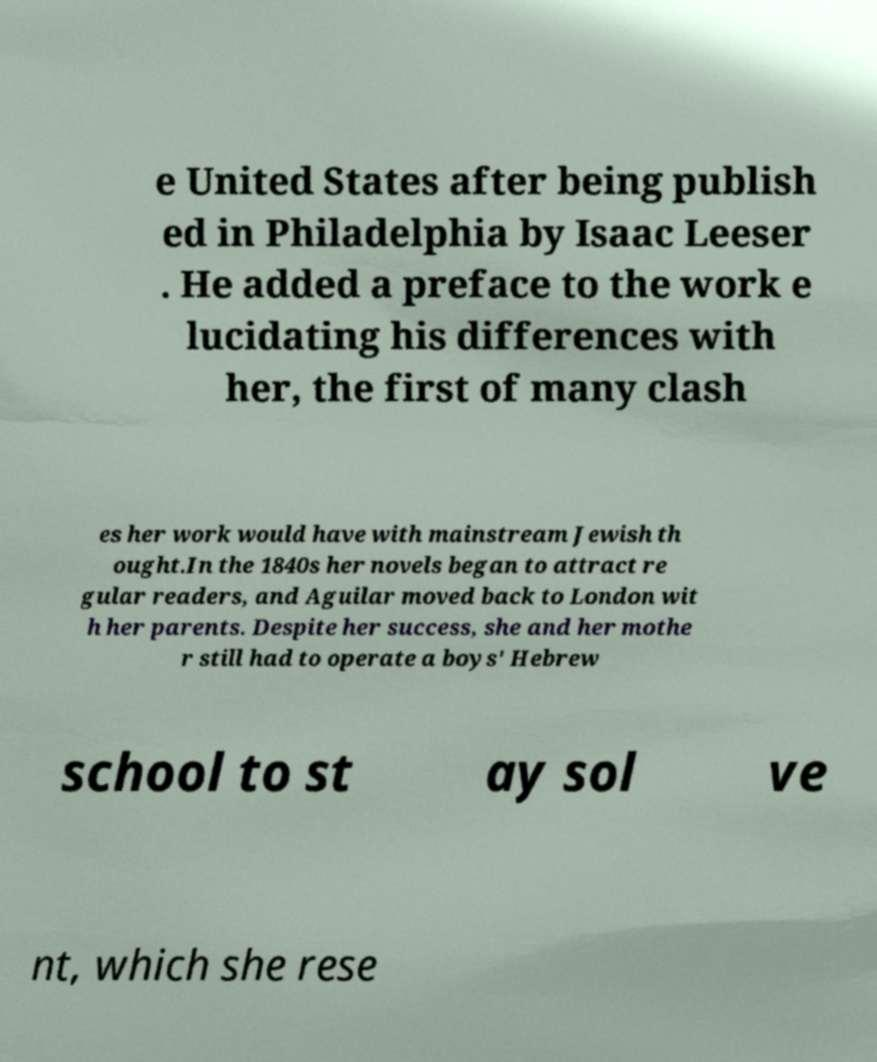Please identify and transcribe the text found in this image. e United States after being publish ed in Philadelphia by Isaac Leeser . He added a preface to the work e lucidating his differences with her, the first of many clash es her work would have with mainstream Jewish th ought.In the 1840s her novels began to attract re gular readers, and Aguilar moved back to London wit h her parents. Despite her success, she and her mothe r still had to operate a boys' Hebrew school to st ay sol ve nt, which she rese 